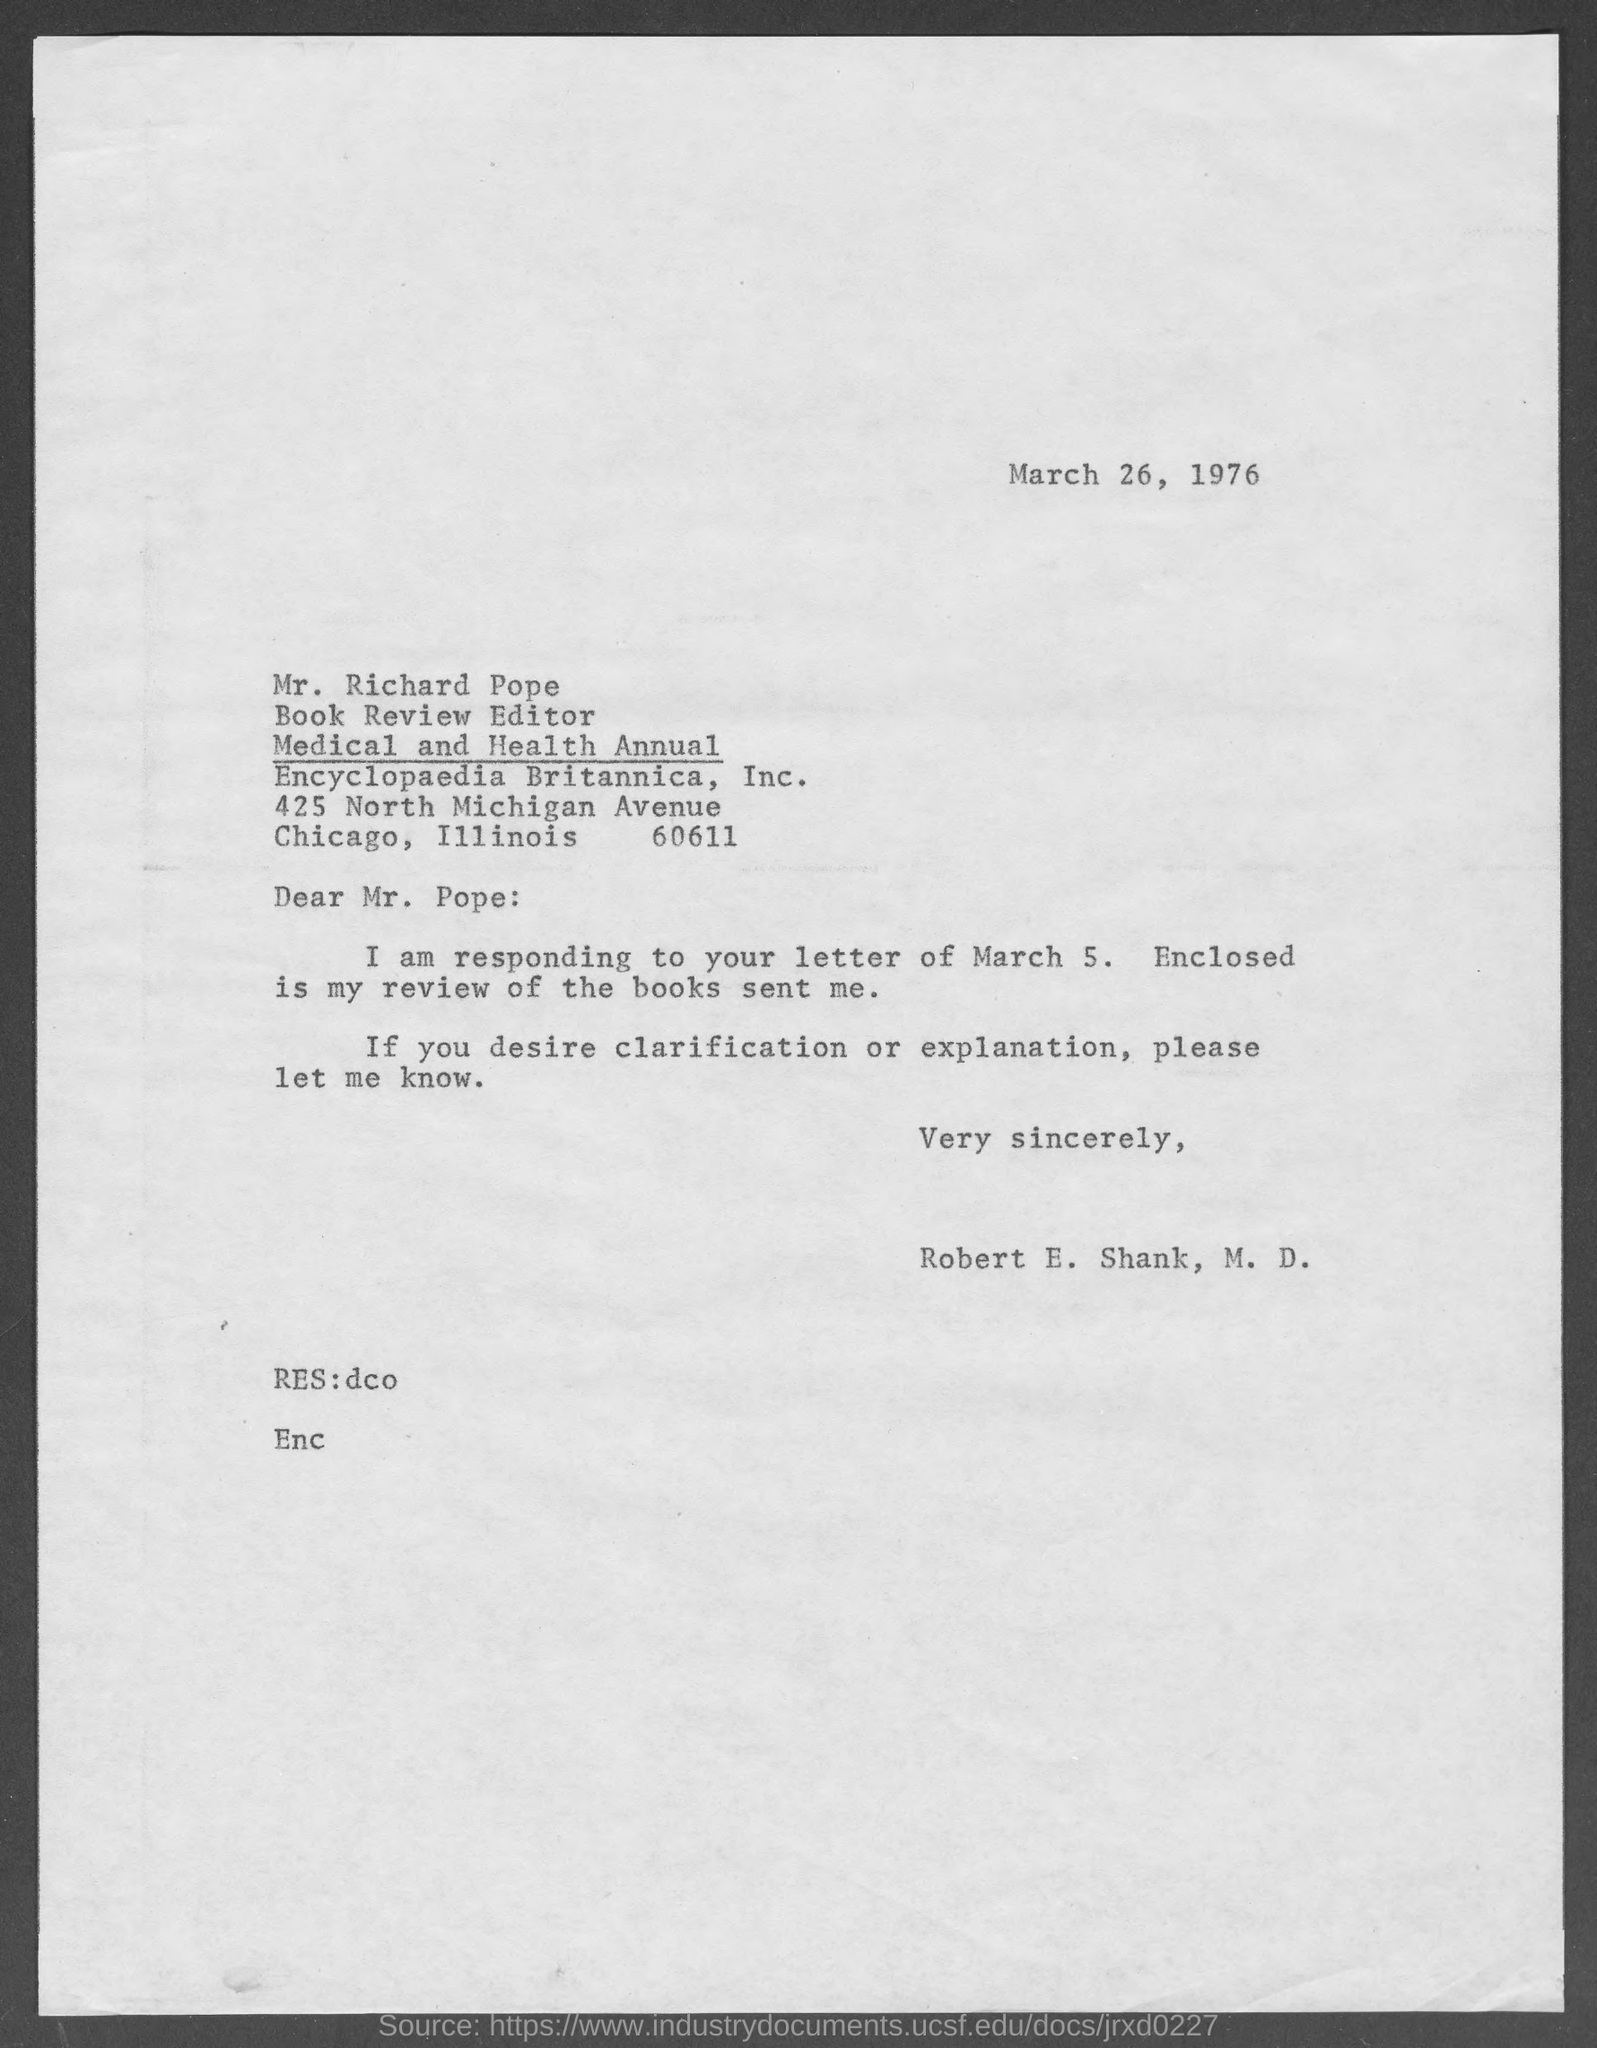What is the date mentioned ?
Make the answer very short. March 26 , 1976. Robert E. Shank is responding to the letter of which date ?
Offer a very short reply. March 5. What is the Designation of Mr. Richard Rope
Keep it short and to the point. Book Review Editor. 